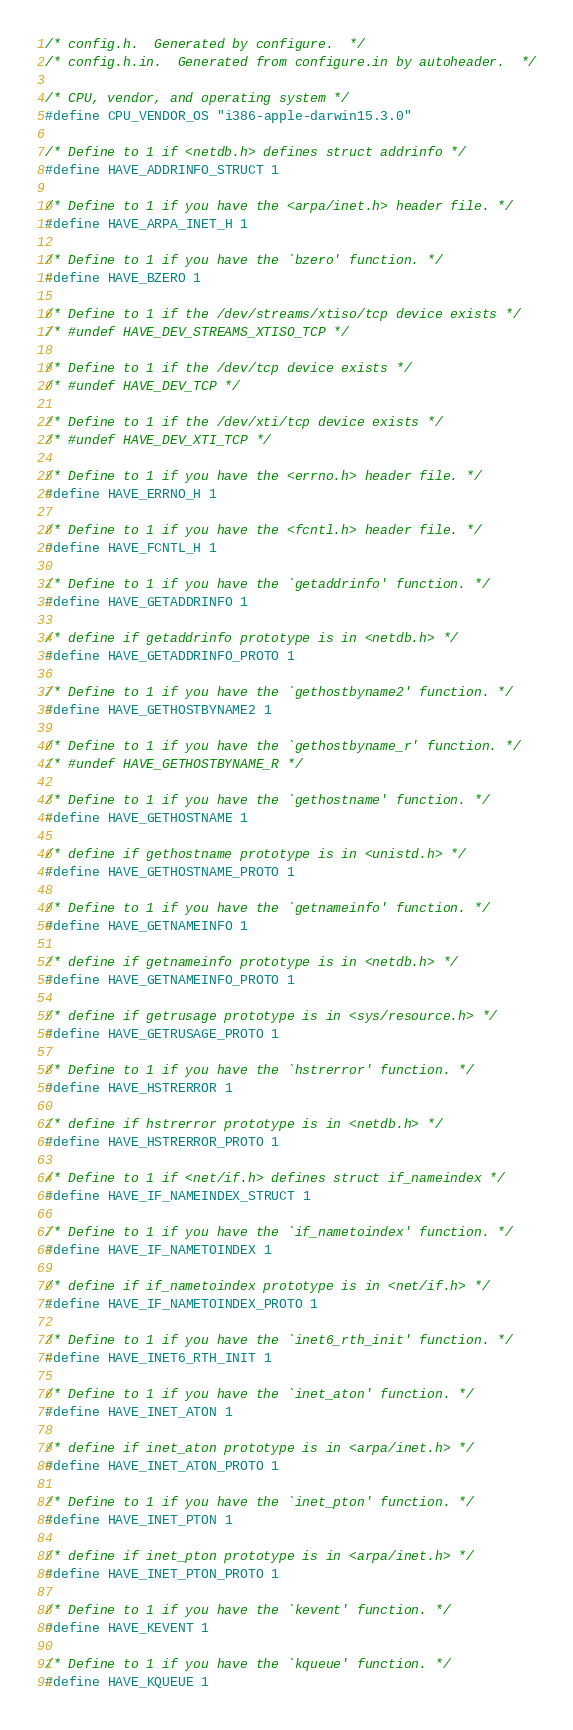<code> <loc_0><loc_0><loc_500><loc_500><_C_>/* config.h.  Generated by configure.  */
/* config.h.in.  Generated from configure.in by autoheader.  */

/* CPU, vendor, and operating system */
#define CPU_VENDOR_OS "i386-apple-darwin15.3.0"

/* Define to 1 if <netdb.h> defines struct addrinfo */
#define HAVE_ADDRINFO_STRUCT 1

/* Define to 1 if you have the <arpa/inet.h> header file. */
#define HAVE_ARPA_INET_H 1

/* Define to 1 if you have the `bzero' function. */
#define HAVE_BZERO 1

/* Define to 1 if the /dev/streams/xtiso/tcp device exists */
/* #undef HAVE_DEV_STREAMS_XTISO_TCP */

/* Define to 1 if the /dev/tcp device exists */
/* #undef HAVE_DEV_TCP */

/* Define to 1 if the /dev/xti/tcp device exists */
/* #undef HAVE_DEV_XTI_TCP */

/* Define to 1 if you have the <errno.h> header file. */
#define HAVE_ERRNO_H 1

/* Define to 1 if you have the <fcntl.h> header file. */
#define HAVE_FCNTL_H 1

/* Define to 1 if you have the `getaddrinfo' function. */
#define HAVE_GETADDRINFO 1

/* define if getaddrinfo prototype is in <netdb.h> */
#define HAVE_GETADDRINFO_PROTO 1

/* Define to 1 if you have the `gethostbyname2' function. */
#define HAVE_GETHOSTBYNAME2 1

/* Define to 1 if you have the `gethostbyname_r' function. */
/* #undef HAVE_GETHOSTBYNAME_R */

/* Define to 1 if you have the `gethostname' function. */
#define HAVE_GETHOSTNAME 1

/* define if gethostname prototype is in <unistd.h> */
#define HAVE_GETHOSTNAME_PROTO 1

/* Define to 1 if you have the `getnameinfo' function. */
#define HAVE_GETNAMEINFO 1

/* define if getnameinfo prototype is in <netdb.h> */
#define HAVE_GETNAMEINFO_PROTO 1

/* define if getrusage prototype is in <sys/resource.h> */
#define HAVE_GETRUSAGE_PROTO 1

/* Define to 1 if you have the `hstrerror' function. */
#define HAVE_HSTRERROR 1

/* define if hstrerror prototype is in <netdb.h> */
#define HAVE_HSTRERROR_PROTO 1

/* Define to 1 if <net/if.h> defines struct if_nameindex */
#define HAVE_IF_NAMEINDEX_STRUCT 1

/* Define to 1 if you have the `if_nametoindex' function. */
#define HAVE_IF_NAMETOINDEX 1

/* define if if_nametoindex prototype is in <net/if.h> */
#define HAVE_IF_NAMETOINDEX_PROTO 1

/* Define to 1 if you have the `inet6_rth_init' function. */
#define HAVE_INET6_RTH_INIT 1

/* Define to 1 if you have the `inet_aton' function. */
#define HAVE_INET_ATON 1

/* define if inet_aton prototype is in <arpa/inet.h> */
#define HAVE_INET_ATON_PROTO 1

/* Define to 1 if you have the `inet_pton' function. */
#define HAVE_INET_PTON 1

/* define if inet_pton prototype is in <arpa/inet.h> */
#define HAVE_INET_PTON_PROTO 1

/* Define to 1 if you have the `kevent' function. */
#define HAVE_KEVENT 1

/* Define to 1 if you have the `kqueue' function. */
#define HAVE_KQUEUE 1
</code> 